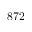<formula> <loc_0><loc_0><loc_500><loc_500>8 7 2</formula> 